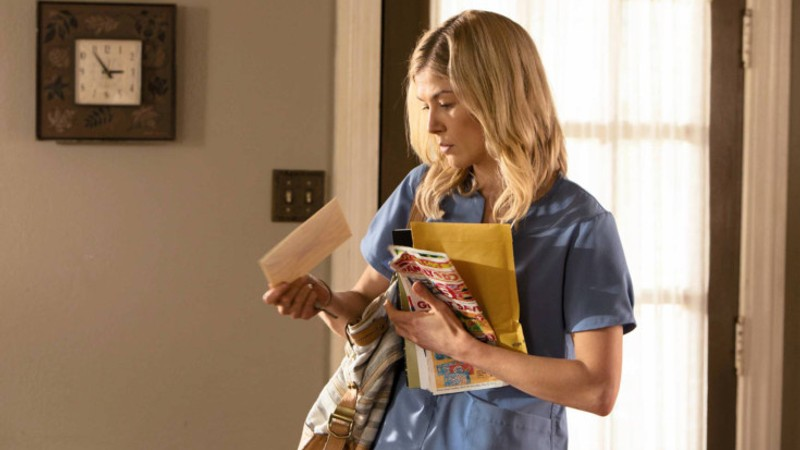Describe the emotions conveyed by the woman in the image. The woman's expression can be interpreted as one of focused concern. Her eyes are intently looking at the folder, suggesting she is deeply engaged in reading or assessing the contents. This expression, coupled with her slightly open mouth, may indicate that she is in a situation requiring careful attention or decision-making, a common scenario in medical or caregiving professions. 